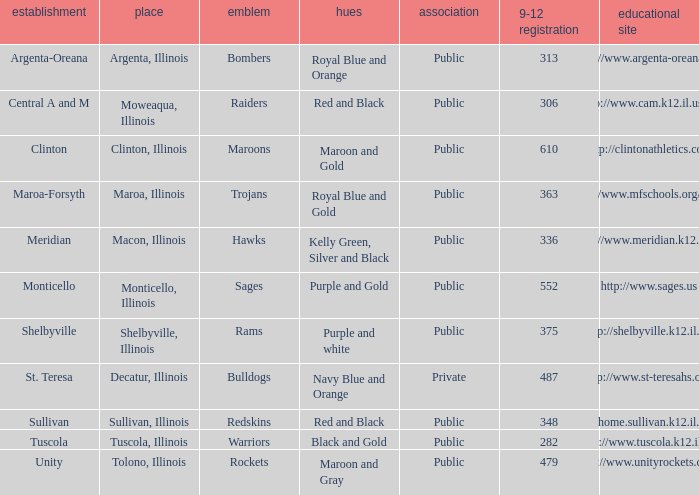How many different combinations of team colors are there in all the schools in Maroa, Illinois? 1.0. 